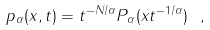<formula> <loc_0><loc_0><loc_500><loc_500>p _ { \alpha } ( x , t ) = t ^ { - N / \alpha } P _ { \alpha } ( x t ^ { - 1 / \alpha } ) \ ,</formula> 